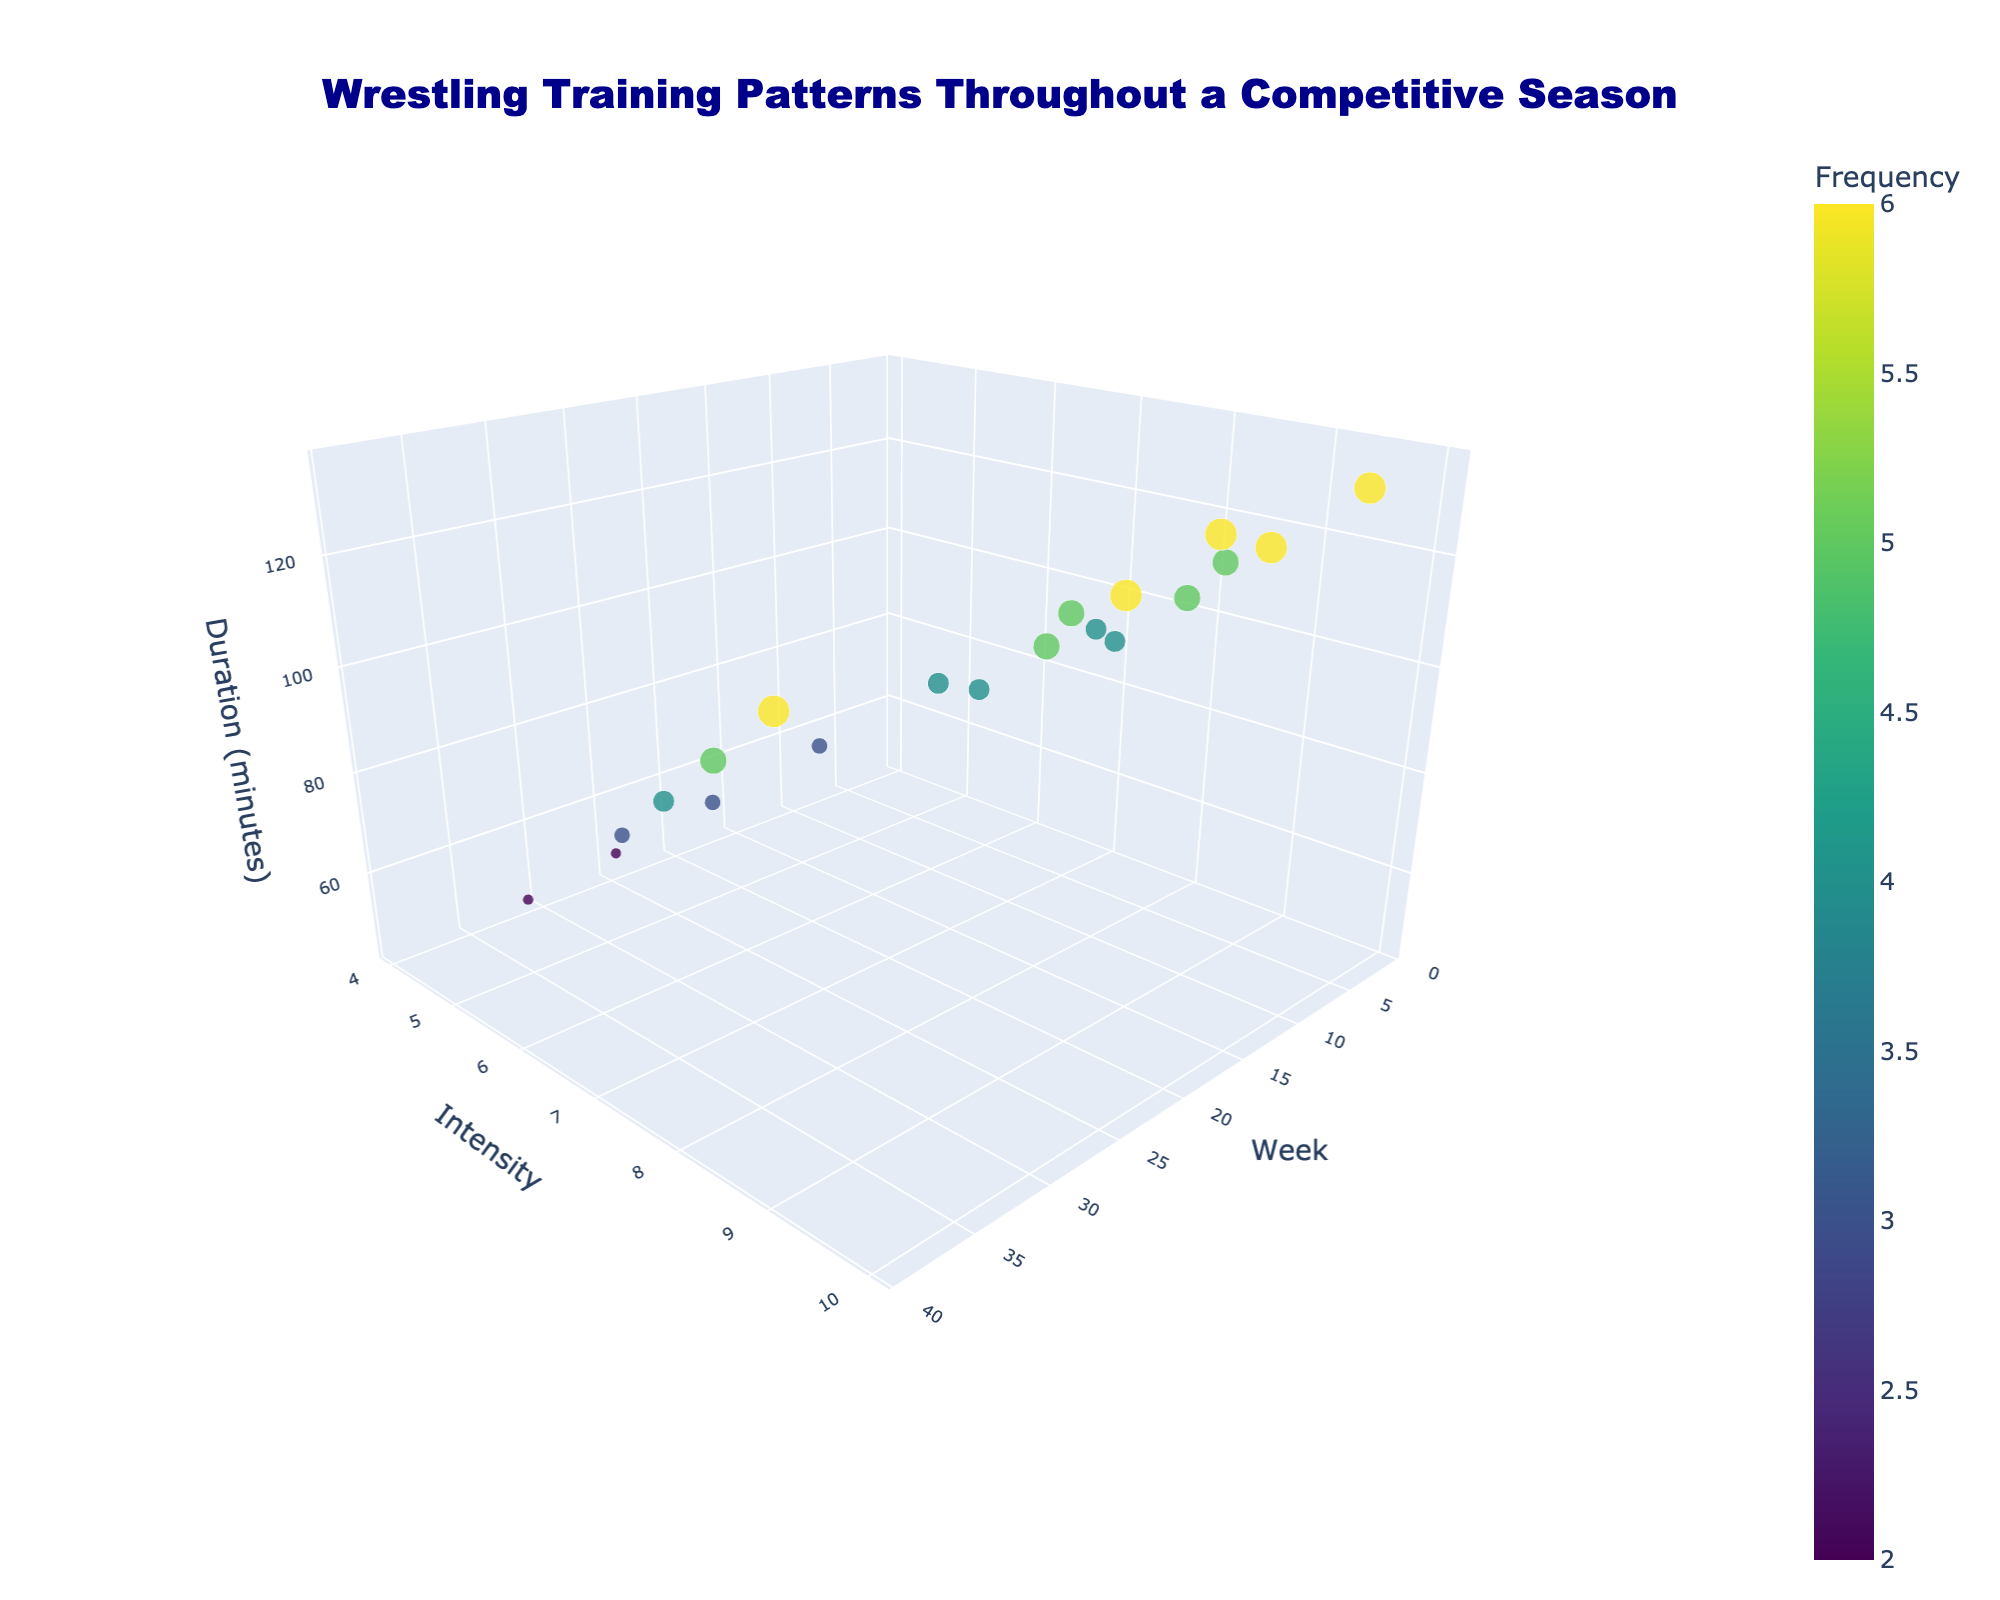How many weeks are displayed in the plot? There are data points for multiple weeks throughout the competitive season. Counting all the distinct weeks visible in the plot, we find there are 20 different weeks.
Answer: 20 What is the frequency of training in Week 5? From the hover text or the size/color of the marker at Week 5, we can see that the frequency of training is 6 sessions per week.
Answer: 6 During which week was the training intensity at its highest? The highest intensity value in the plot is 10. By looking at the markers' positions, we find that this occurs in Week 7 and Week 19.
Answer: Week 7, Week 19 What are the duration and frequency of training in Week 33? By locating Week 33 on the x-axis and checking the marker, we find that the duration is 75 minutes, and the frequency is 3.
Answer: 75 minutes, 3 What is the range of training intensity throughout the season? By examining the y-axis values for intensity, the lowest intensity is 4, and the highest is 10. The range is 10 - 4.
Answer: 6 Which week has an intensity of 5 and what is its corresponding duration? By finding the data point with an intensity of 5 on the y-axis, we see that this occurs in Week 29, with a corresponding duration of 60 minutes.
Answer: Week 29, 60 minutes How does the training duration change from Week 1 to Week 7? In Week 1, the duration was 90 minutes. In Week 7, the duration increased to 135 minutes. The change is 135 - 90.
Answer: Increase by 45 minutes What can you infer about the overall trend in training intensity and duration from Week 1 to Week 39? Observing the pattern, there's an initial increase in both intensity and duration from Week 1, peaking around the middle weeks, and then gradually decreasing towards Week 39.
Answer: Initial increase, peak, then decrease What is the frequency of training during the week with the shortest duration? The shortest duration is found by locating the smallest point on the z-axis, which is Week 31 with 45 minutes. The frequency for this week is 2 sessions.
Answer: 2 Between which weeks does the training duration decrease, and by how much? Comparing Week 25 (90 minutes) and Week 27 (75 minutes) we see that the duration decreases by 15 minutes.
Answer: Week 25 to Week 27, decrease by 15 minutes 